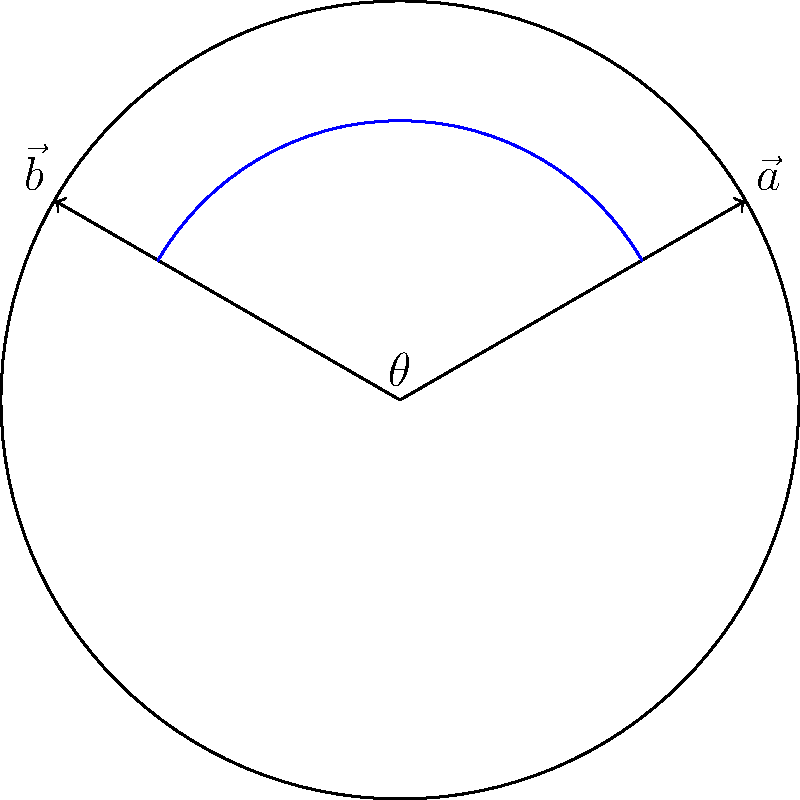As a personal chef, you're arranging appetizers on a circular tray for a holiday party. Two appetizer platters are represented by vectors $\vec{a}$ and $\vec{b}$ on the tray, as shown in the diagram. Vector $\vec{a}$ makes an angle of $\frac{\pi}{6}$ with the positive x-axis, while vector $\vec{b}$ makes an angle of $\frac{5\pi}{6}$ with the positive x-axis. Calculate the angle $\theta$ between these two vectors. To find the angle between two vectors, we can use the dot product formula:

$$\cos \theta = \frac{\vec{a} \cdot \vec{b}}{|\vec{a}||\vec{b}|}$$

Given:
- $\vec{a}$ makes an angle of $\frac{\pi}{6}$ with the positive x-axis
- $\vec{b}$ makes an angle of $\frac{5\pi}{6}$ with the positive x-axis

Step 1: Express vectors in component form
$\vec{a} = (|\vec{a}|\cos\frac{\pi}{6}, |\vec{a}|\sin\frac{\pi}{6})$
$\vec{b} = (|\vec{b}|\cos\frac{5\pi}{6}, |\vec{b}|\sin\frac{5\pi}{6})$

Step 2: Calculate the dot product
$\vec{a} \cdot \vec{b} = |\vec{a}||\vec{b}|(\cos\frac{\pi}{6}\cos\frac{5\pi}{6} + \sin\frac{\pi}{6}\sin\frac{5\pi}{6})$

Step 3: Use the cosine of the difference formula
$\cos(\frac{5\pi}{6} - \frac{\pi}{6}) = \cos\frac{2\pi}{3} = -\frac{1}{2}$

Step 4: Substitute into the dot product formula
$\cos \theta = \frac{\vec{a} \cdot \vec{b}}{|\vec{a}||\vec{b}|} = -\frac{1}{2}$

Step 5: Solve for $\theta$
$\theta = \arccos(-\frac{1}{2}) = \frac{2\pi}{3}$

Therefore, the angle between the two vectors is $\frac{2\pi}{3}$ radians or 120°.
Answer: $\frac{2\pi}{3}$ radians or 120° 